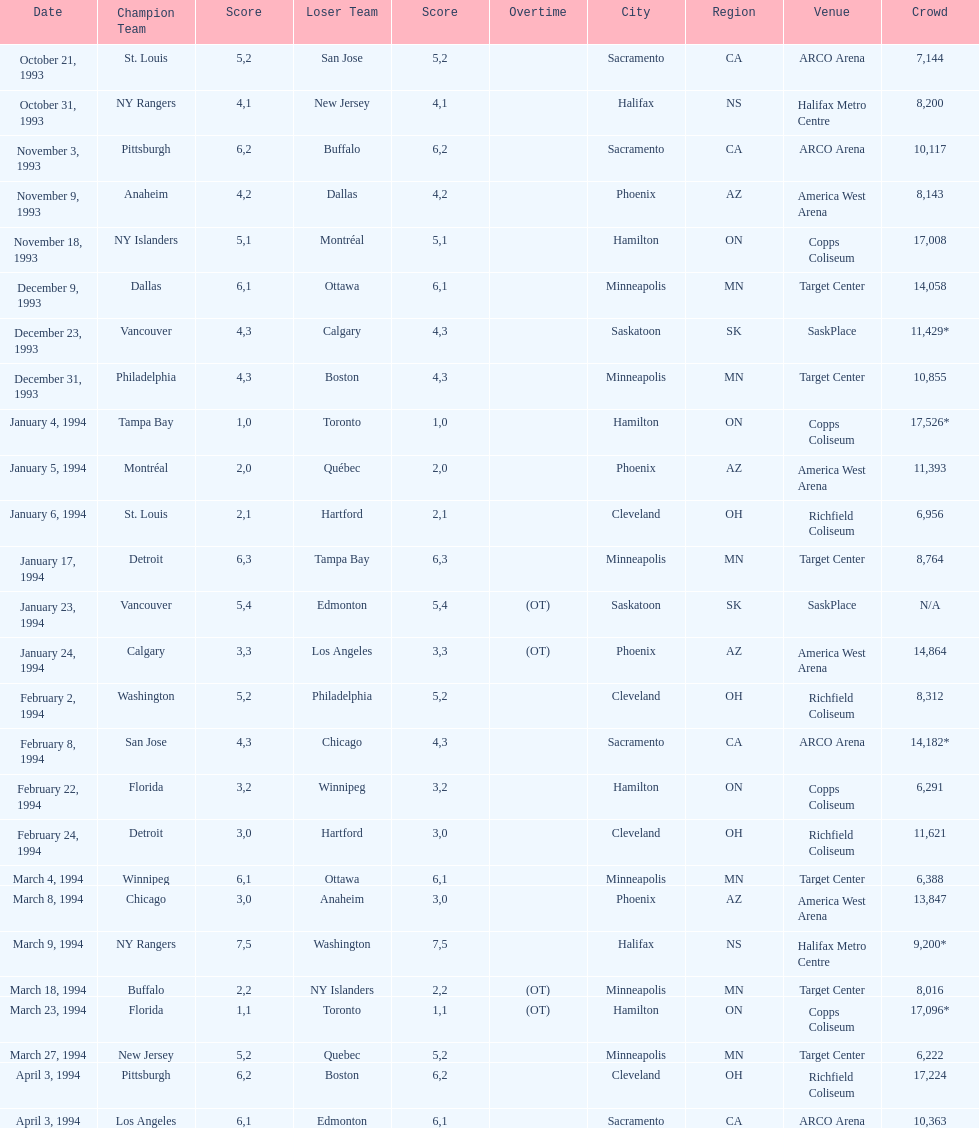How many games have been held in minneapolis? 6. 